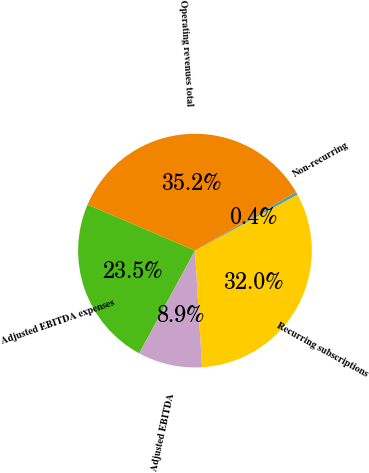<chart> <loc_0><loc_0><loc_500><loc_500><pie_chart><fcel>Recurring subscriptions<fcel>Non-recurring<fcel>Operating revenues total<fcel>Adjusted EBITDA expenses<fcel>Adjusted EBITDA<nl><fcel>31.98%<fcel>0.43%<fcel>35.18%<fcel>23.52%<fcel>8.88%<nl></chart> 